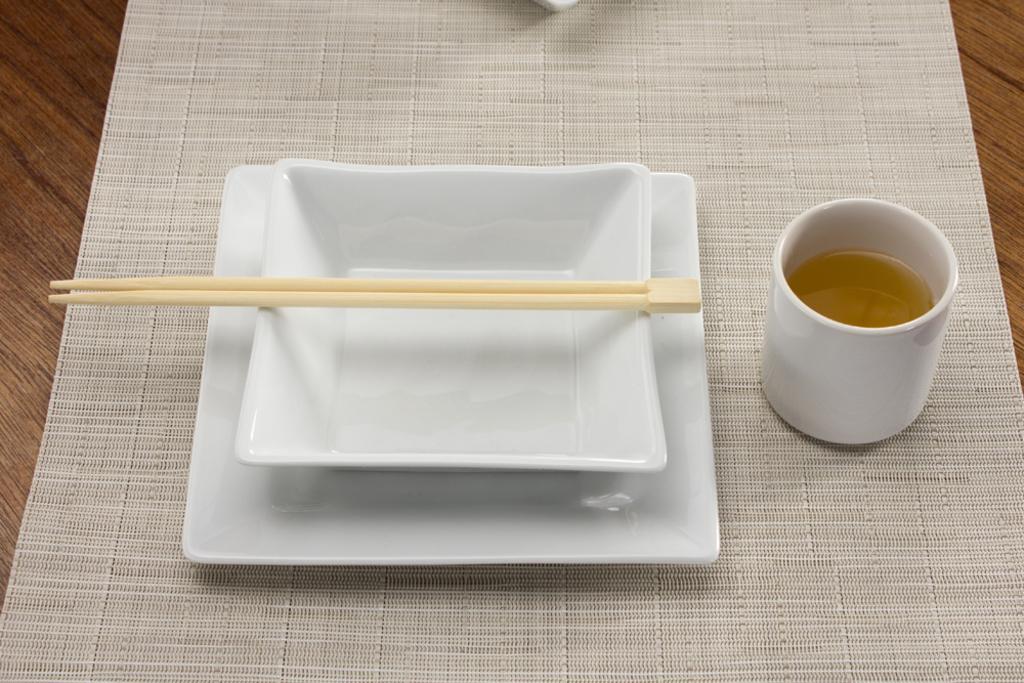Describe this image in one or two sentences. We can see two plates, chopsticks and a cup of drink, table mat on the table. 